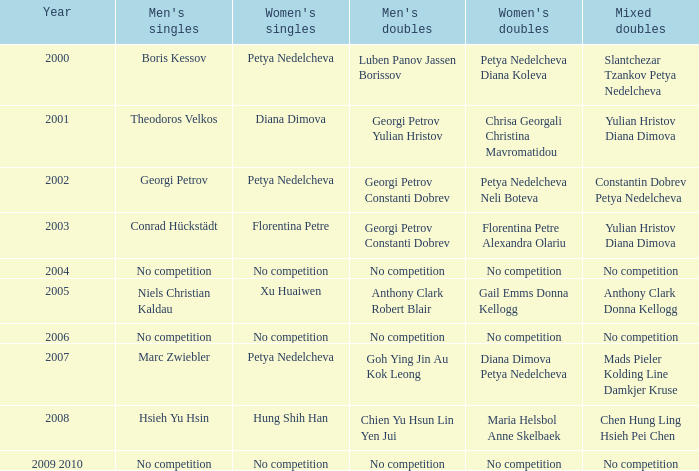What is the year when Conrad Hückstädt won Men's Single? 2003.0. 